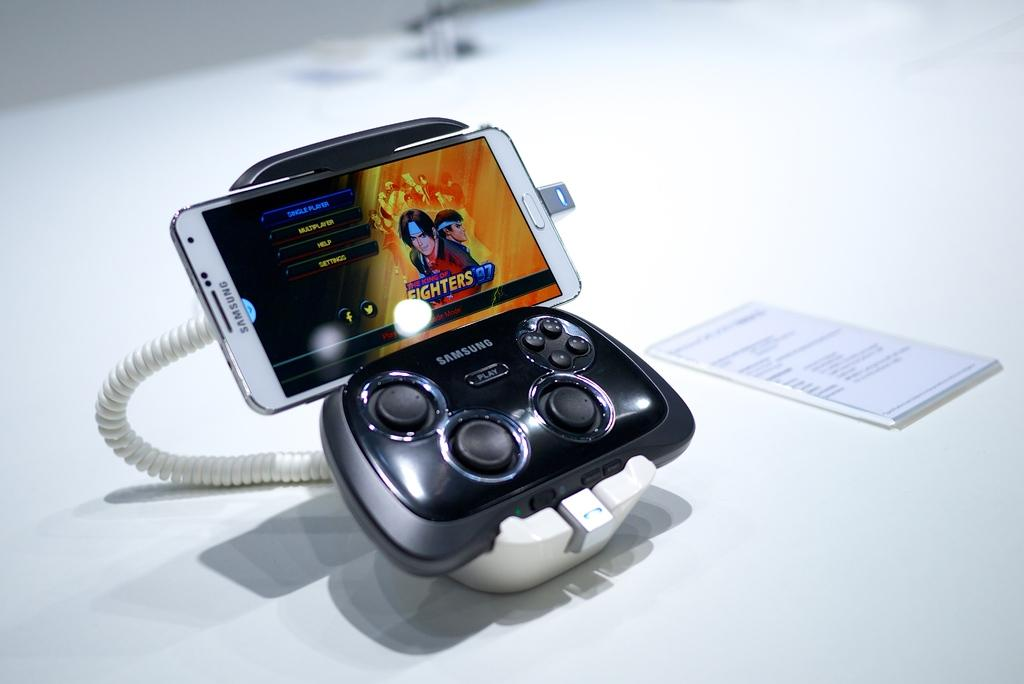<image>
Present a compact description of the photo's key features. A Samsung game controller hooked up to a Samsung device has a version of a game called The King Of Fighters '97 displayed. 